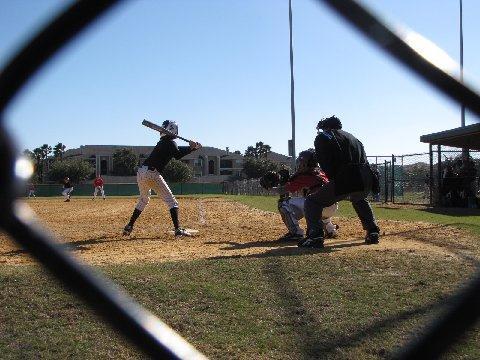How many people are there?
Give a very brief answer. 3. 